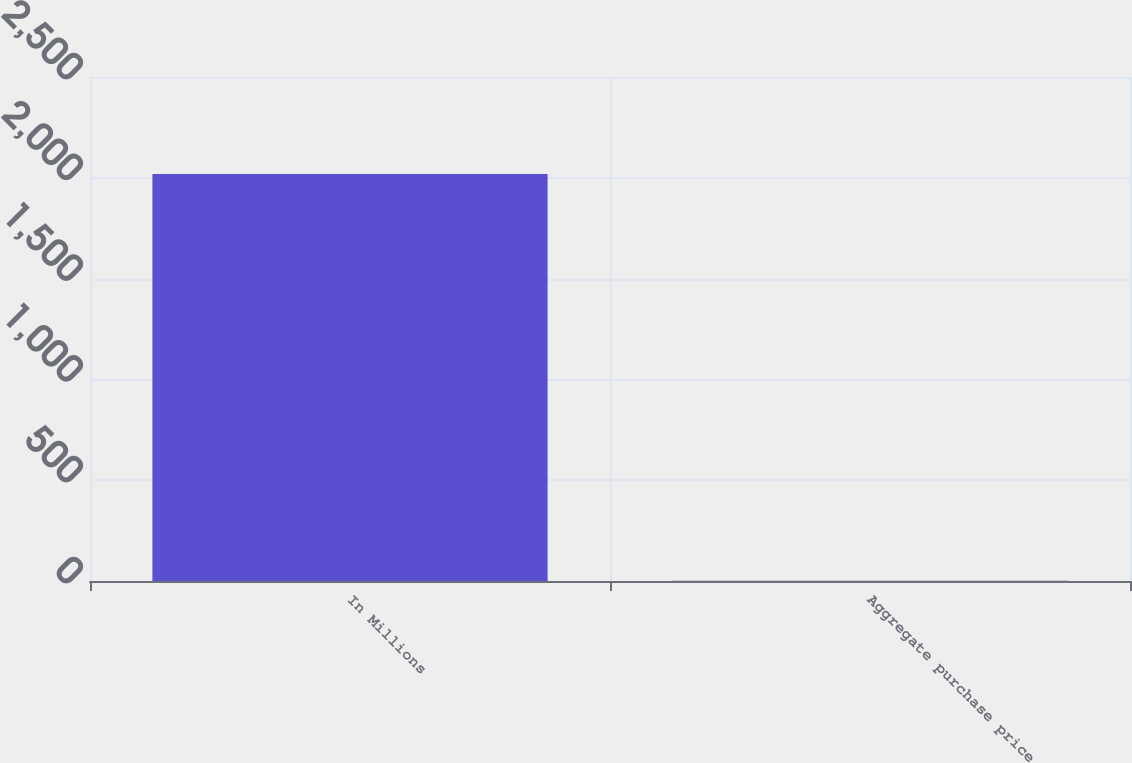Convert chart to OTSL. <chart><loc_0><loc_0><loc_500><loc_500><bar_chart><fcel>In Millions<fcel>Aggregate purchase price<nl><fcel>2019<fcel>1.1<nl></chart> 